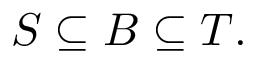<formula> <loc_0><loc_0><loc_500><loc_500>S \subseteq B \subseteq T .</formula> 